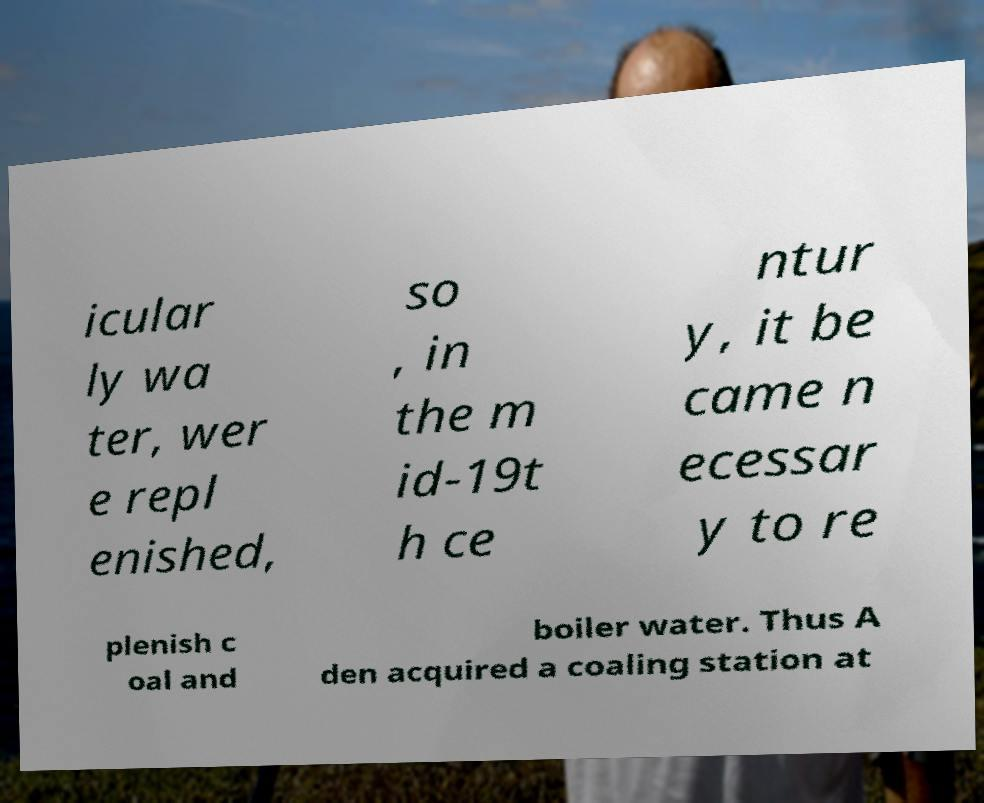Please identify and transcribe the text found in this image. icular ly wa ter, wer e repl enished, so , in the m id-19t h ce ntur y, it be came n ecessar y to re plenish c oal and boiler water. Thus A den acquired a coaling station at 